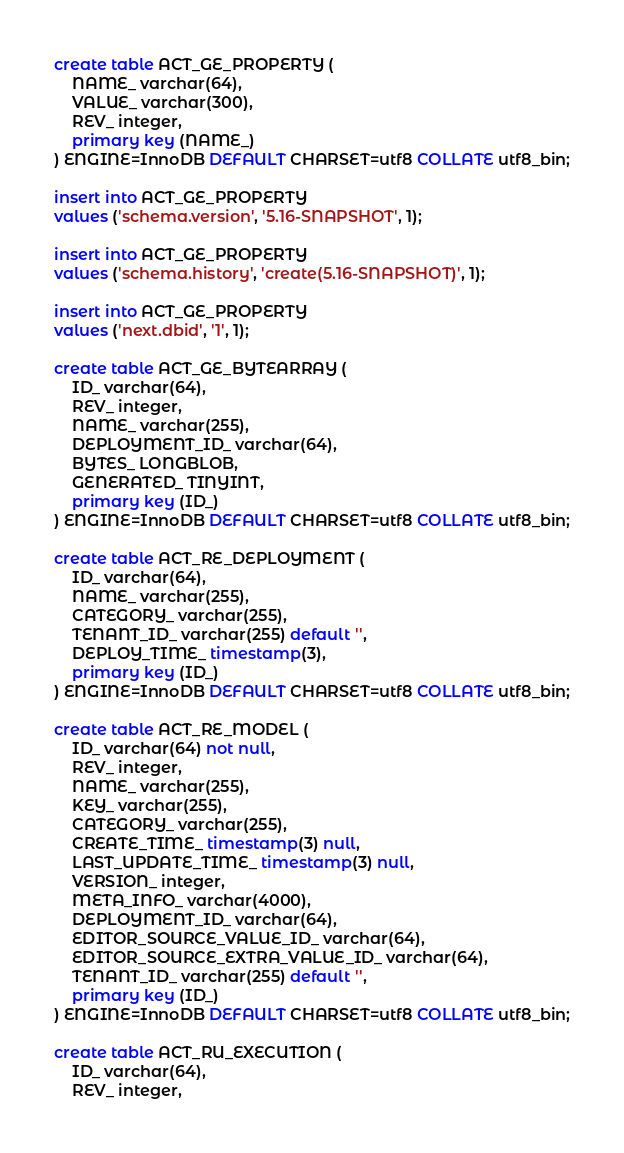Convert code to text. <code><loc_0><loc_0><loc_500><loc_500><_SQL_>create table ACT_GE_PROPERTY (
    NAME_ varchar(64),
    VALUE_ varchar(300),
    REV_ integer,
    primary key (NAME_)
) ENGINE=InnoDB DEFAULT CHARSET=utf8 COLLATE utf8_bin;

insert into ACT_GE_PROPERTY
values ('schema.version', '5.16-SNAPSHOT', 1);

insert into ACT_GE_PROPERTY
values ('schema.history', 'create(5.16-SNAPSHOT)', 1);

insert into ACT_GE_PROPERTY
values ('next.dbid', '1', 1);

create table ACT_GE_BYTEARRAY (
    ID_ varchar(64),
    REV_ integer,
    NAME_ varchar(255),
    DEPLOYMENT_ID_ varchar(64),
    BYTES_ LONGBLOB,
    GENERATED_ TINYINT,
    primary key (ID_)
) ENGINE=InnoDB DEFAULT CHARSET=utf8 COLLATE utf8_bin;

create table ACT_RE_DEPLOYMENT (
    ID_ varchar(64),
    NAME_ varchar(255),
    CATEGORY_ varchar(255),
    TENANT_ID_ varchar(255) default '',
    DEPLOY_TIME_ timestamp(3),
    primary key (ID_)
) ENGINE=InnoDB DEFAULT CHARSET=utf8 COLLATE utf8_bin;

create table ACT_RE_MODEL (
    ID_ varchar(64) not null,
    REV_ integer,
    NAME_ varchar(255),
    KEY_ varchar(255),
    CATEGORY_ varchar(255),
    CREATE_TIME_ timestamp(3) null,
    LAST_UPDATE_TIME_ timestamp(3) null,
    VERSION_ integer,
    META_INFO_ varchar(4000),
    DEPLOYMENT_ID_ varchar(64),
    EDITOR_SOURCE_VALUE_ID_ varchar(64),
    EDITOR_SOURCE_EXTRA_VALUE_ID_ varchar(64),
    TENANT_ID_ varchar(255) default '',
    primary key (ID_)
) ENGINE=InnoDB DEFAULT CHARSET=utf8 COLLATE utf8_bin;

create table ACT_RU_EXECUTION (
    ID_ varchar(64),
    REV_ integer,</code> 